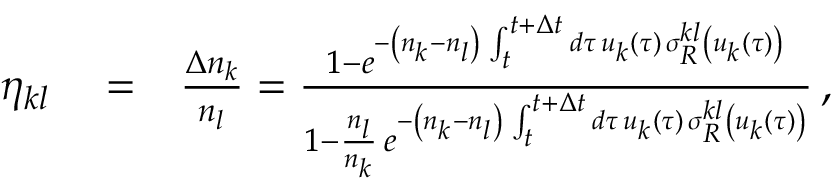Convert formula to latex. <formula><loc_0><loc_0><loc_500><loc_500>\begin{array} { r l r } { \eta _ { k l } } & = } & { \frac { \Delta n _ { k } } { n _ { l } } = \frac { 1 - e ^ { - \left ( n _ { k } - n _ { l } \right ) \, \int _ { t } ^ { t + \Delta t } d \tau \, u _ { k } ( \tau ) \, \sigma _ { R } ^ { k l } \left ( u _ { k } ( \tau ) \right ) } } { 1 - \frac { n _ { l } } { n _ { k } } \, e ^ { - \left ( n _ { k } - n _ { l } \right ) \, \int _ { t } ^ { t + \Delta t } d \tau \, u _ { k } ( \tau ) \, \sigma _ { R } ^ { k l } \left ( u _ { k } ( \tau ) \right ) } } \, , } \end{array}</formula> 